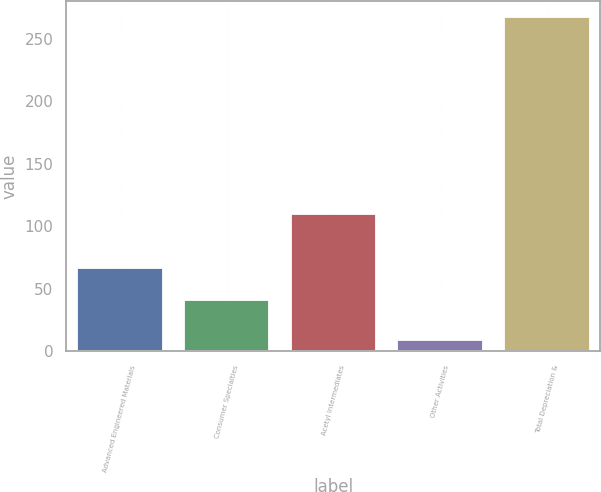Convert chart to OTSL. <chart><loc_0><loc_0><loc_500><loc_500><bar_chart><fcel>Advanced Engineered Materials<fcel>Consumer Specialties<fcel>Acetyl Intermediates<fcel>Other Activities<fcel>Total Depreciation &<nl><fcel>66.8<fcel>41<fcel>110<fcel>9<fcel>267<nl></chart> 